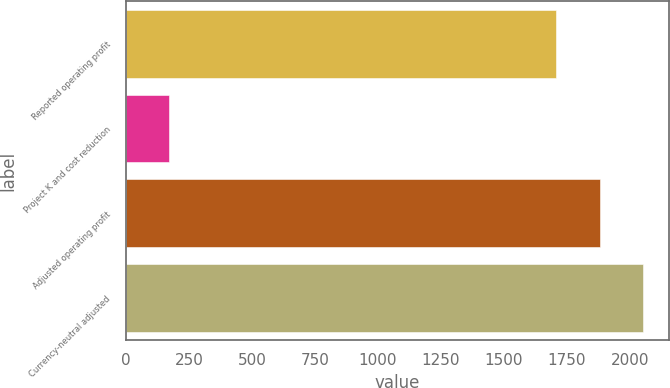<chart> <loc_0><loc_0><loc_500><loc_500><bar_chart><fcel>Reported operating profit<fcel>Project K and cost reduction<fcel>Adjusted operating profit<fcel>Currency-neutral adjusted<nl><fcel>1706<fcel>173<fcel>1880<fcel>2051<nl></chart> 